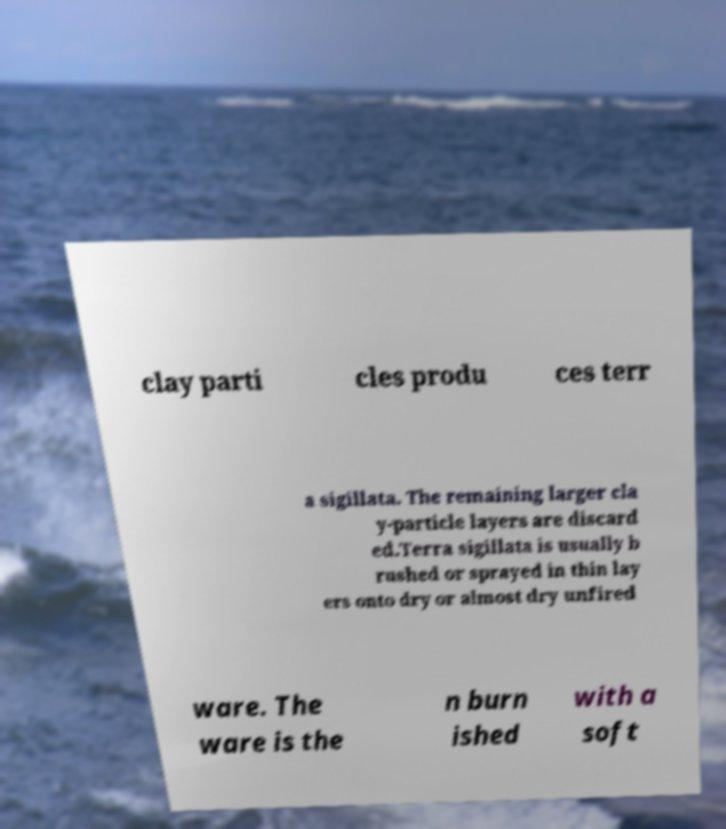For documentation purposes, I need the text within this image transcribed. Could you provide that? clay parti cles produ ces terr a sigillata. The remaining larger cla y-particle layers are discard ed.Terra sigillata is usually b rushed or sprayed in thin lay ers onto dry or almost dry unfired ware. The ware is the n burn ished with a soft 